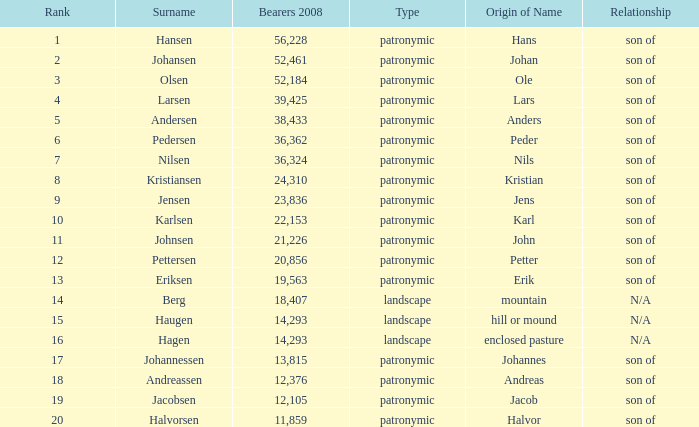What is Type, when Number of Bearers 2008 is greater than 12.376, when Rank is greater than 3, and when Etymology is Son of Jens? Patronymic. 